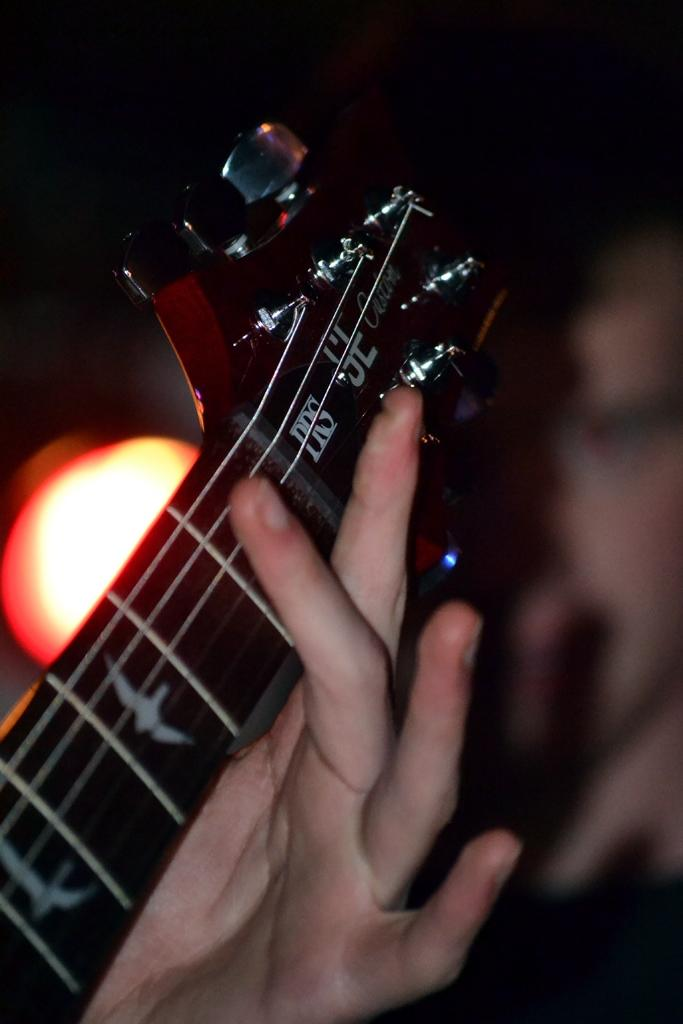What musical instrument is featured in the image? There is a side of a guitar in the image. What type of coil is wrapped around the guitar in the image? There is no coil present around the guitar in the image. What month is the guitar being played in the image? The image does not provide information about the month or time of year. 